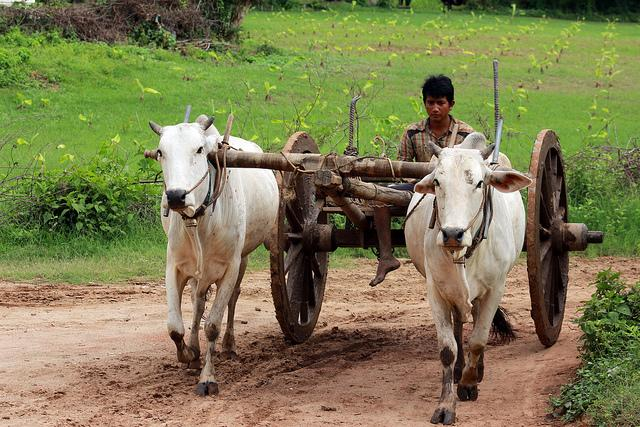What is behind the animals?

Choices:
A) wheels
B) cookies
C) ladder
D) baby wheels 